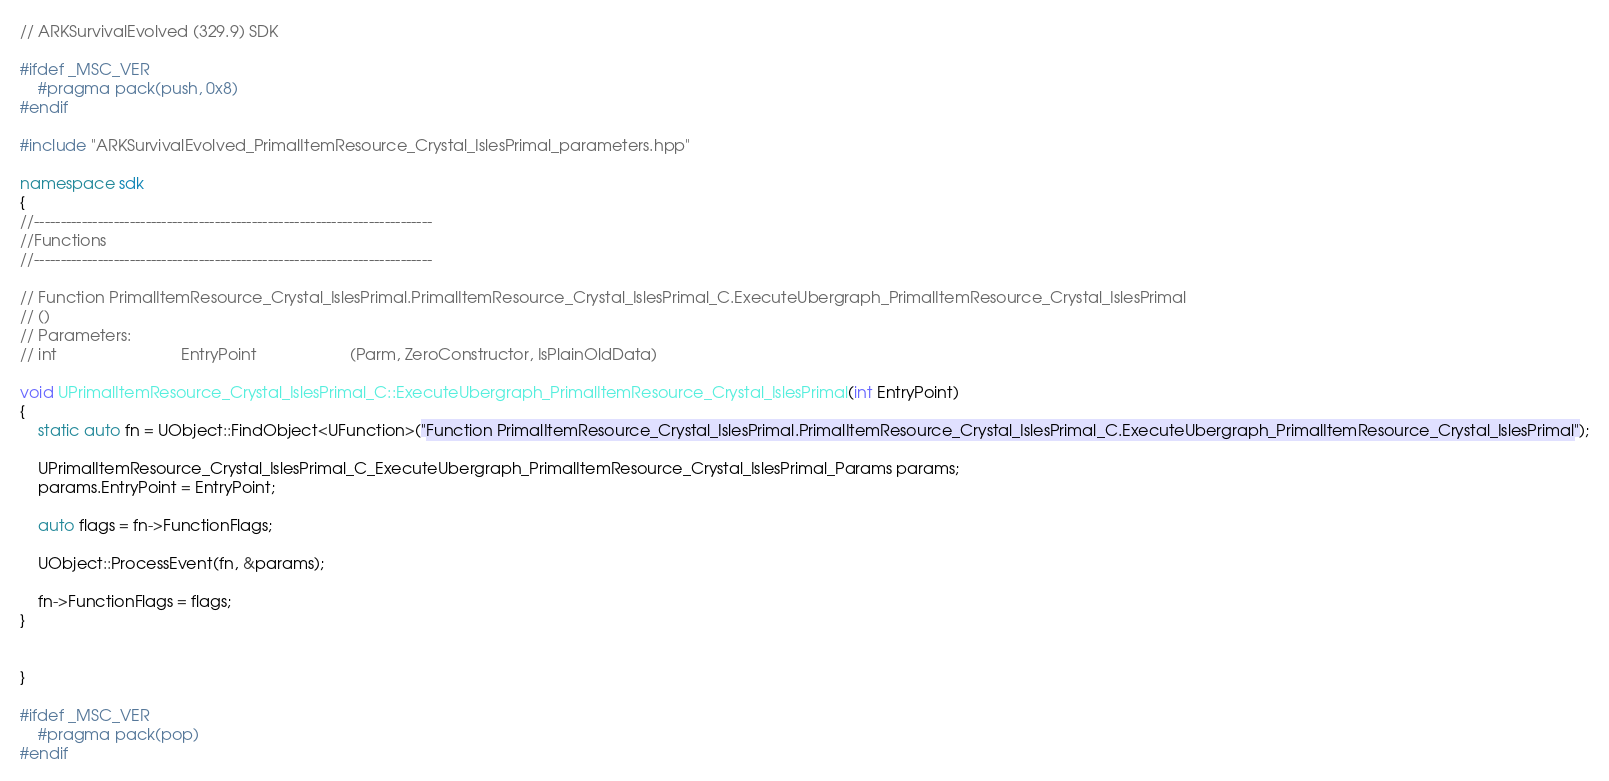Convert code to text. <code><loc_0><loc_0><loc_500><loc_500><_C++_>// ARKSurvivalEvolved (329.9) SDK

#ifdef _MSC_VER
	#pragma pack(push, 0x8)
#endif

#include "ARKSurvivalEvolved_PrimalItemResource_Crystal_IslesPrimal_parameters.hpp"

namespace sdk
{
//---------------------------------------------------------------------------
//Functions
//---------------------------------------------------------------------------

// Function PrimalItemResource_Crystal_IslesPrimal.PrimalItemResource_Crystal_IslesPrimal_C.ExecuteUbergraph_PrimalItemResource_Crystal_IslesPrimal
// ()
// Parameters:
// int                            EntryPoint                     (Parm, ZeroConstructor, IsPlainOldData)

void UPrimalItemResource_Crystal_IslesPrimal_C::ExecuteUbergraph_PrimalItemResource_Crystal_IslesPrimal(int EntryPoint)
{
	static auto fn = UObject::FindObject<UFunction>("Function PrimalItemResource_Crystal_IslesPrimal.PrimalItemResource_Crystal_IslesPrimal_C.ExecuteUbergraph_PrimalItemResource_Crystal_IslesPrimal");

	UPrimalItemResource_Crystal_IslesPrimal_C_ExecuteUbergraph_PrimalItemResource_Crystal_IslesPrimal_Params params;
	params.EntryPoint = EntryPoint;

	auto flags = fn->FunctionFlags;

	UObject::ProcessEvent(fn, &params);

	fn->FunctionFlags = flags;
}


}

#ifdef _MSC_VER
	#pragma pack(pop)
#endif
</code> 